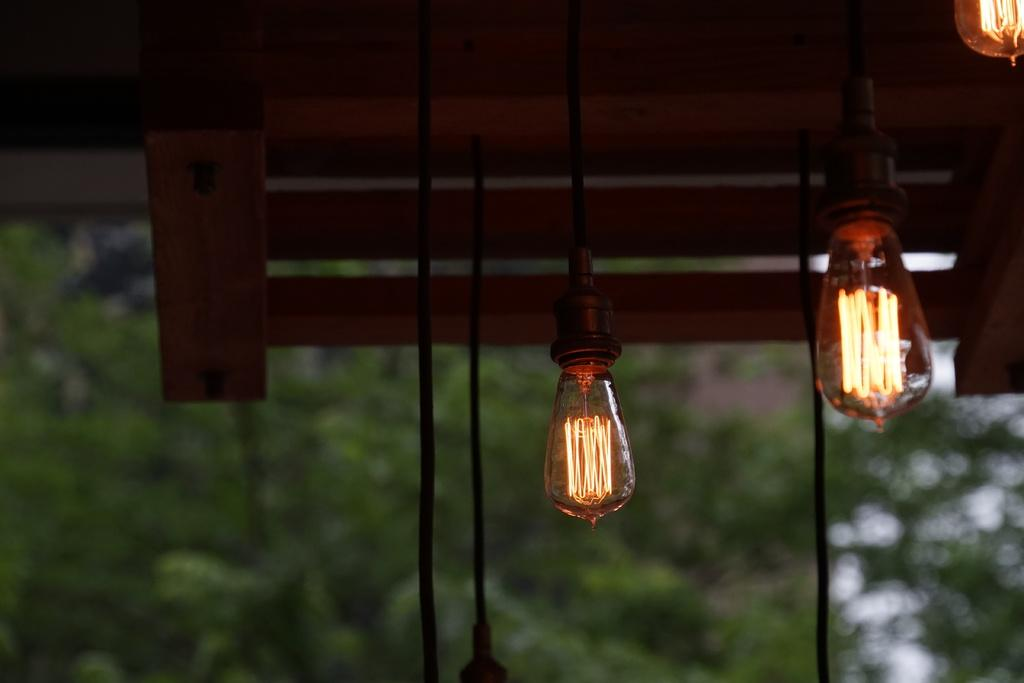What is hanging down in the image? There are lights hanging down in the image. What color is the background of the lights? The background of the lights is blue. How many legs can be seen on the stage in the image? There is no stage present in the image, and therefore no legs can be seen. What type of bit is being used by the performer on the stage in the image? There is no performer or stage present in the image, and therefore no bit can be seen. 